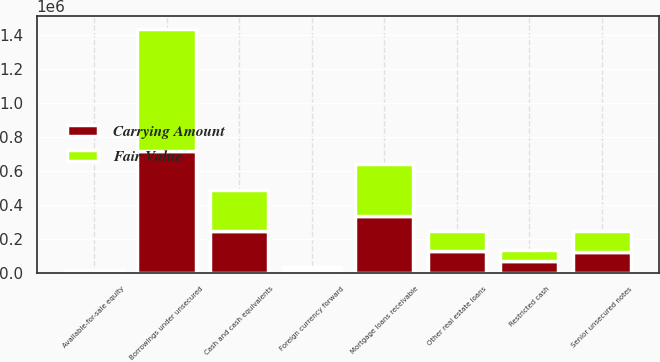Convert chart to OTSL. <chart><loc_0><loc_0><loc_500><loc_500><stacked_bar_chart><ecel><fcel>Mortgage loans receivable<fcel>Other real estate loans<fcel>Available-for-sale equity<fcel>Cash and cash equivalents<fcel>Restricted cash<fcel>Foreign currency forward<fcel>Borrowings under unsecured<fcel>Senior unsecured notes<nl><fcel>Fair Value<fcel>306120<fcel>121379<fcel>7269<fcel>243777<fcel>65526<fcel>15604<fcel>719000<fcel>123430<nl><fcel>Carrying Amount<fcel>332508<fcel>125480<fcel>7269<fcel>243777<fcel>65526<fcel>15604<fcel>719000<fcel>123430<nl></chart> 